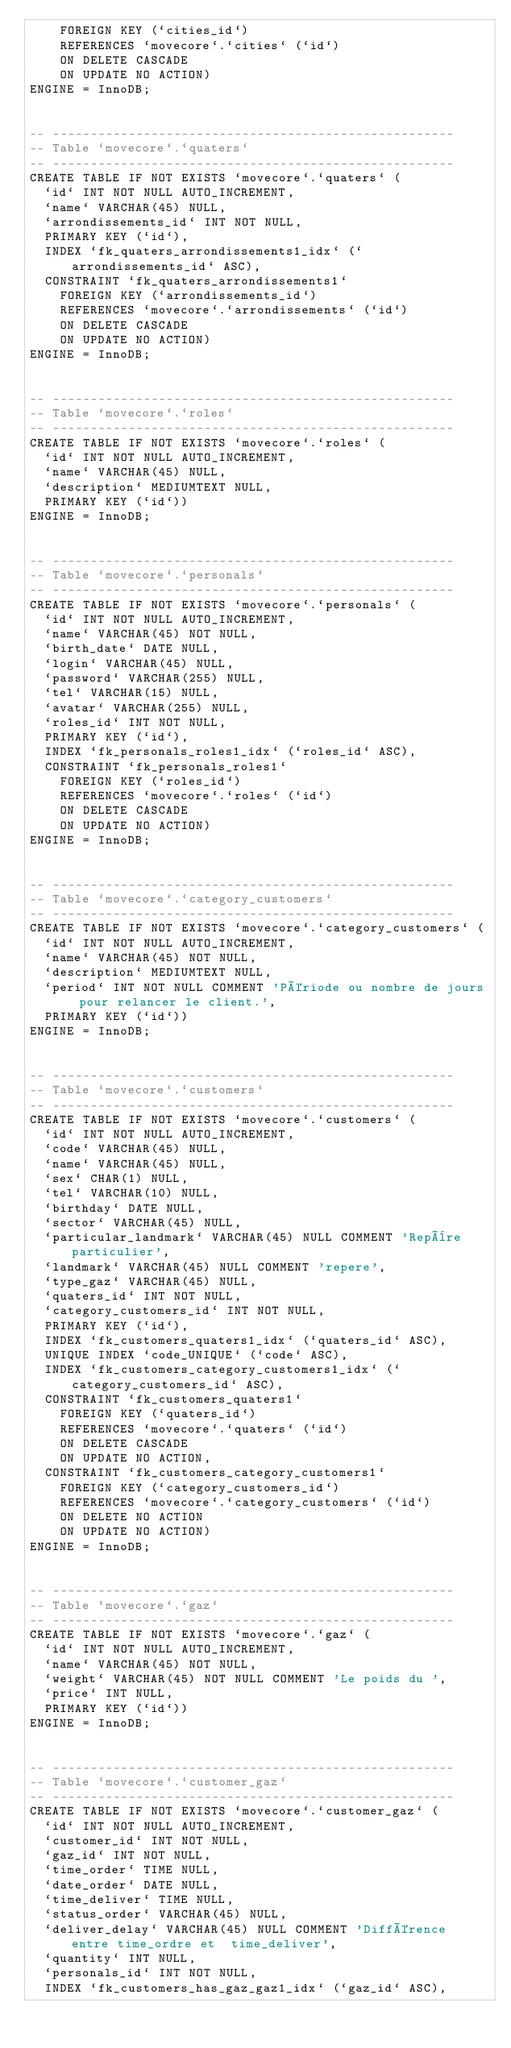Convert code to text. <code><loc_0><loc_0><loc_500><loc_500><_SQL_>    FOREIGN KEY (`cities_id`)
    REFERENCES `movecore`.`cities` (`id`)
    ON DELETE CASCADE
    ON UPDATE NO ACTION)
ENGINE = InnoDB;


-- -----------------------------------------------------
-- Table `movecore`.`quaters`
-- -----------------------------------------------------
CREATE TABLE IF NOT EXISTS `movecore`.`quaters` (
  `id` INT NOT NULL AUTO_INCREMENT,
  `name` VARCHAR(45) NULL,
  `arrondissements_id` INT NOT NULL,
  PRIMARY KEY (`id`),
  INDEX `fk_quaters_arrondissements1_idx` (`arrondissements_id` ASC),
  CONSTRAINT `fk_quaters_arrondissements1`
    FOREIGN KEY (`arrondissements_id`)
    REFERENCES `movecore`.`arrondissements` (`id`)
    ON DELETE CASCADE
    ON UPDATE NO ACTION)
ENGINE = InnoDB;


-- -----------------------------------------------------
-- Table `movecore`.`roles`
-- -----------------------------------------------------
CREATE TABLE IF NOT EXISTS `movecore`.`roles` (
  `id` INT NOT NULL AUTO_INCREMENT,
  `name` VARCHAR(45) NULL,
  `description` MEDIUMTEXT NULL,
  PRIMARY KEY (`id`))
ENGINE = InnoDB;


-- -----------------------------------------------------
-- Table `movecore`.`personals`
-- -----------------------------------------------------
CREATE TABLE IF NOT EXISTS `movecore`.`personals` (
  `id` INT NOT NULL AUTO_INCREMENT,
  `name` VARCHAR(45) NOT NULL,
  `birth_date` DATE NULL,
  `login` VARCHAR(45) NULL,
  `password` VARCHAR(255) NULL,
  `tel` VARCHAR(15) NULL,
  `avatar` VARCHAR(255) NULL,
  `roles_id` INT NOT NULL,
  PRIMARY KEY (`id`),
  INDEX `fk_personals_roles1_idx` (`roles_id` ASC),
  CONSTRAINT `fk_personals_roles1`
    FOREIGN KEY (`roles_id`)
    REFERENCES `movecore`.`roles` (`id`)
    ON DELETE CASCADE
    ON UPDATE NO ACTION)
ENGINE = InnoDB;


-- -----------------------------------------------------
-- Table `movecore`.`category_customers`
-- -----------------------------------------------------
CREATE TABLE IF NOT EXISTS `movecore`.`category_customers` (
  `id` INT NOT NULL AUTO_INCREMENT,
  `name` VARCHAR(45) NOT NULL,
  `description` MEDIUMTEXT NULL,
  `period` INT NOT NULL COMMENT 'Période ou nombre de jours pour relancer le client.',
  PRIMARY KEY (`id`))
ENGINE = InnoDB;


-- -----------------------------------------------------
-- Table `movecore`.`customers`
-- -----------------------------------------------------
CREATE TABLE IF NOT EXISTS `movecore`.`customers` (
  `id` INT NOT NULL AUTO_INCREMENT,
  `code` VARCHAR(45) NULL,
  `name` VARCHAR(45) NULL,
  `sex` CHAR(1) NULL,
  `tel` VARCHAR(10) NULL,
  `birthday` DATE NULL,
  `sector` VARCHAR(45) NULL,
  `particular_landmark` VARCHAR(45) NULL COMMENT 'Repère particulier',
  `landmark` VARCHAR(45) NULL COMMENT 'repere',
  `type_gaz` VARCHAR(45) NULL,
  `quaters_id` INT NOT NULL,
  `category_customers_id` INT NOT NULL,
  PRIMARY KEY (`id`),
  INDEX `fk_customers_quaters1_idx` (`quaters_id` ASC),
  UNIQUE INDEX `code_UNIQUE` (`code` ASC),
  INDEX `fk_customers_category_customers1_idx` (`category_customers_id` ASC),
  CONSTRAINT `fk_customers_quaters1`
    FOREIGN KEY (`quaters_id`)
    REFERENCES `movecore`.`quaters` (`id`)
    ON DELETE CASCADE
    ON UPDATE NO ACTION,
  CONSTRAINT `fk_customers_category_customers1`
    FOREIGN KEY (`category_customers_id`)
    REFERENCES `movecore`.`category_customers` (`id`)
    ON DELETE NO ACTION
    ON UPDATE NO ACTION)
ENGINE = InnoDB;


-- -----------------------------------------------------
-- Table `movecore`.`gaz`
-- -----------------------------------------------------
CREATE TABLE IF NOT EXISTS `movecore`.`gaz` (
  `id` INT NOT NULL AUTO_INCREMENT,
  `name` VARCHAR(45) NOT NULL,
  `weight` VARCHAR(45) NOT NULL COMMENT 'Le poids du ',
  `price` INT NULL,
  PRIMARY KEY (`id`))
ENGINE = InnoDB;


-- -----------------------------------------------------
-- Table `movecore`.`customer_gaz`
-- -----------------------------------------------------
CREATE TABLE IF NOT EXISTS `movecore`.`customer_gaz` (
  `id` INT NOT NULL AUTO_INCREMENT,
  `customer_id` INT NOT NULL,
  `gaz_id` INT NOT NULL,
  `time_order` TIME NULL,
  `date_order` DATE NULL,
  `time_deliver` TIME NULL,
  `status_order` VARCHAR(45) NULL,
  `deliver_delay` VARCHAR(45) NULL COMMENT 'Différence entre time_ordre et  time_deliver',
  `quantity` INT NULL,
  `personals_id` INT NOT NULL,
  INDEX `fk_customers_has_gaz_gaz1_idx` (`gaz_id` ASC),</code> 